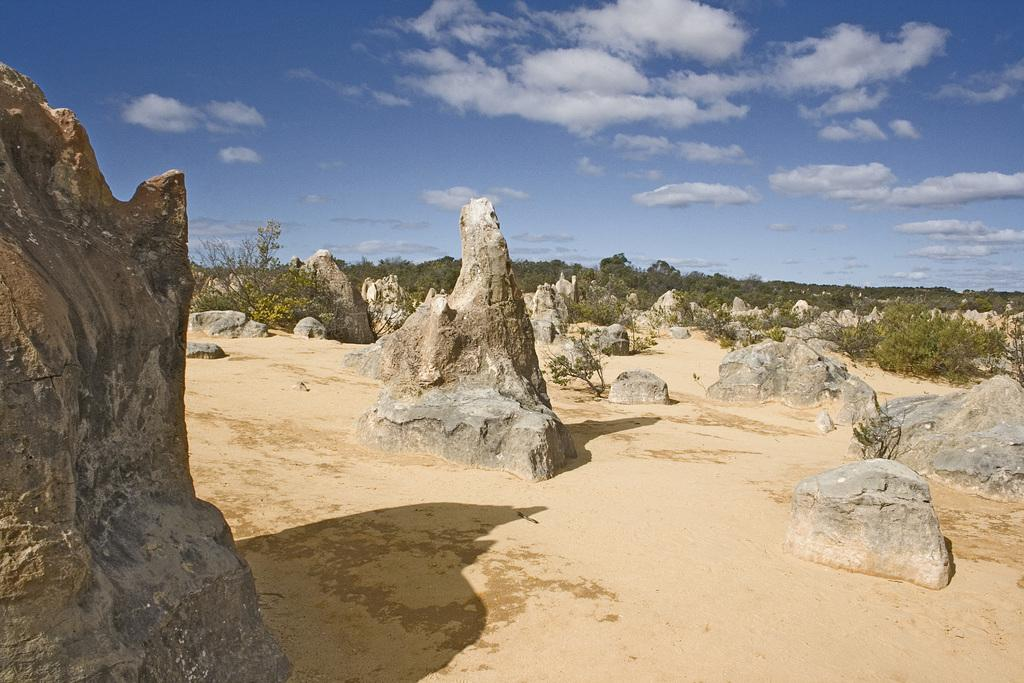What type of natural elements can be seen in the image? There are rocks and trees in the image. What is the color of the sky in the image? The sky is blue and white in color. Can you hear the whistle of the wind in the image? There is no sound present in the image, so it is not possible to hear a whistle. 